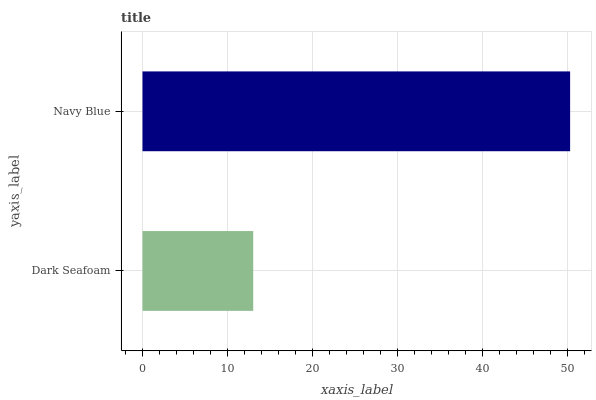Is Dark Seafoam the minimum?
Answer yes or no. Yes. Is Navy Blue the maximum?
Answer yes or no. Yes. Is Navy Blue the minimum?
Answer yes or no. No. Is Navy Blue greater than Dark Seafoam?
Answer yes or no. Yes. Is Dark Seafoam less than Navy Blue?
Answer yes or no. Yes. Is Dark Seafoam greater than Navy Blue?
Answer yes or no. No. Is Navy Blue less than Dark Seafoam?
Answer yes or no. No. Is Navy Blue the high median?
Answer yes or no. Yes. Is Dark Seafoam the low median?
Answer yes or no. Yes. Is Dark Seafoam the high median?
Answer yes or no. No. Is Navy Blue the low median?
Answer yes or no. No. 